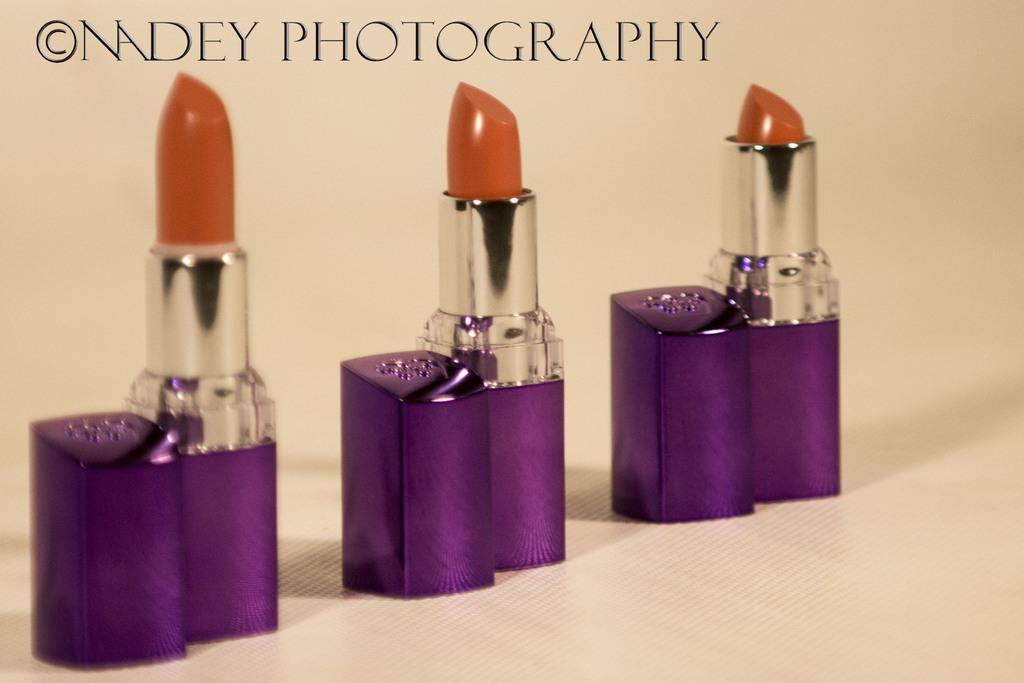What type of cosmetic product is visible in the image? There are lipsticks in the image. What is the color of the surface on which the lipsticks are placed? The lipsticks are on a white surface. Is there any text present in the image? Yes, there is text on the top of the image. How many cherries are placed on top of the lipsticks in the image? There are no cherries present in the image. What is the height of the lipsticks in the image? The height of the lipsticks cannot be determined from the image alone, as there is no reference point for comparison. 